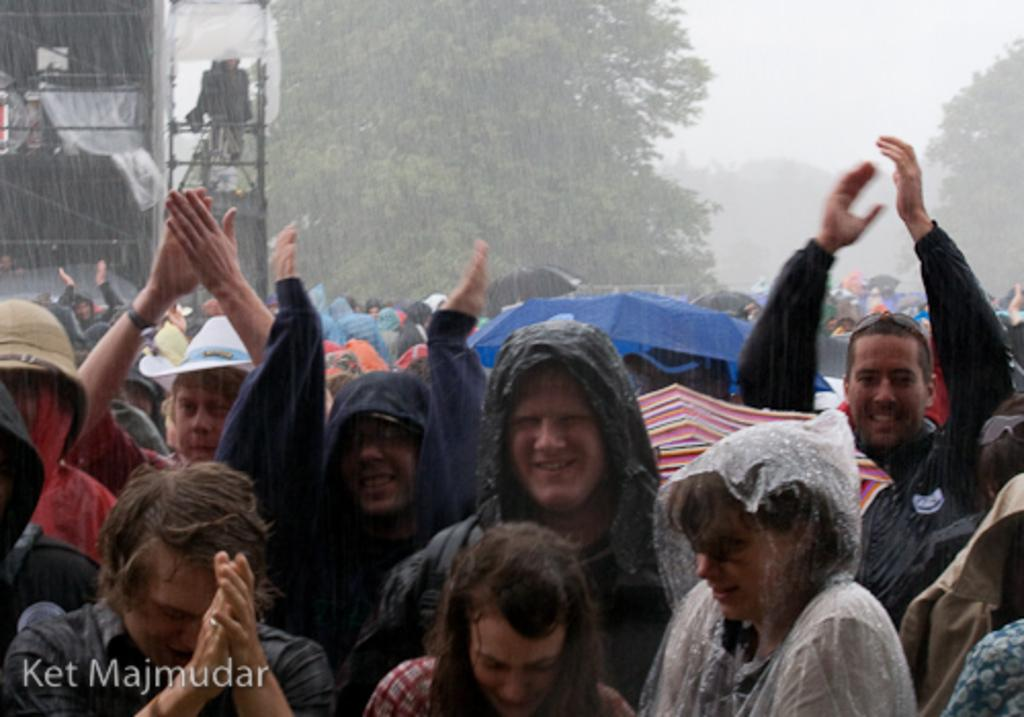What is happening on the road in the image? There is a crowd on the road in the image. What are people using to protect themselves from the weather in the image? Umbrellas are visible in the image. What type of vegetation can be seen in the image? There are trees in the image. What type of structures are present in the image? Houses are present in the image. What is visible in the sky in the image? The sky is visible in the image. What might suggest that the image was taken during a specific type of weather? The image may have been taken during a rainy day, as umbrellas are visible. Where is the wheel located in the image? There is no wheel present in the image. What type of bomb can be seen in the image? There is no bomb present in the image. 